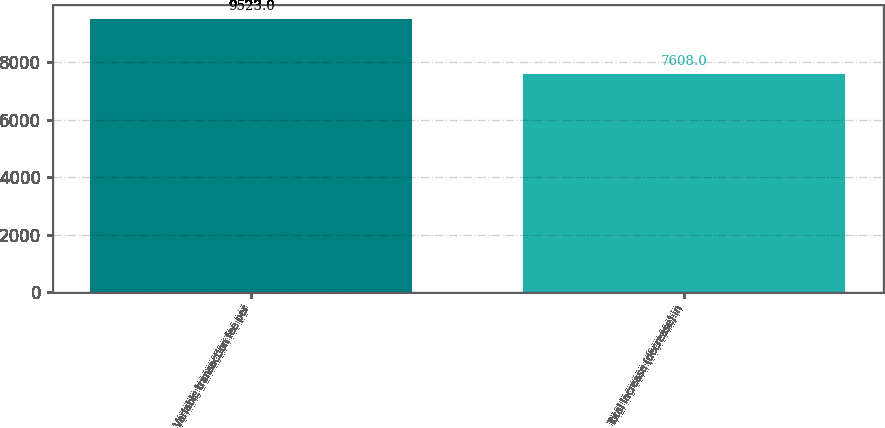Convert chart. <chart><loc_0><loc_0><loc_500><loc_500><bar_chart><fcel>Variable transaction fee per<fcel>Total increase (decrease) in<nl><fcel>9523<fcel>7608<nl></chart> 